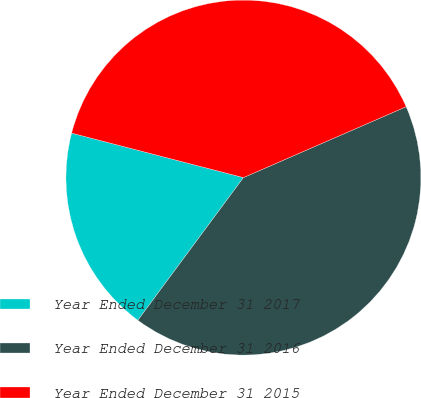Convert chart. <chart><loc_0><loc_0><loc_500><loc_500><pie_chart><fcel>Year Ended December 31 2017<fcel>Year Ended December 31 2016<fcel>Year Ended December 31 2015<nl><fcel>18.89%<fcel>41.68%<fcel>39.43%<nl></chart> 